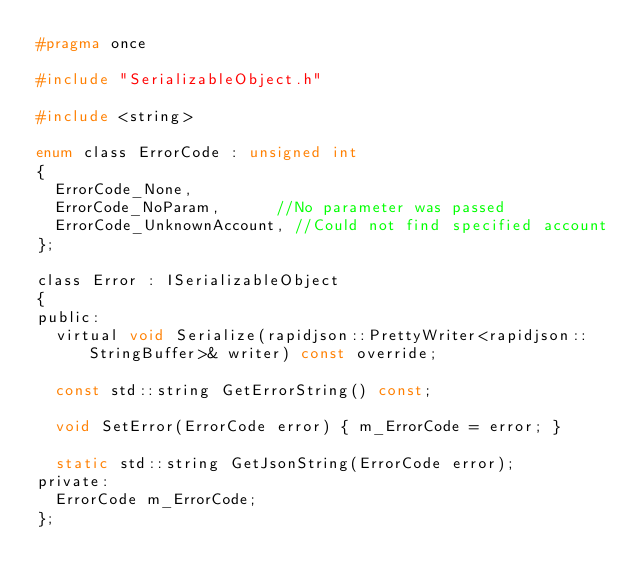<code> <loc_0><loc_0><loc_500><loc_500><_C_>#pragma once

#include "SerializableObject.h"

#include <string>

enum class ErrorCode : unsigned int
{
	ErrorCode_None,
	ErrorCode_NoParam,			//No parameter was passed
	ErrorCode_UnknownAccount,	//Could not find specified account
};

class Error : ISerializableObject
{
public:
	virtual void Serialize(rapidjson::PrettyWriter<rapidjson::StringBuffer>& writer) const override;

	const std::string GetErrorString() const;

	void SetError(ErrorCode error) { m_ErrorCode = error; }

	static std::string GetJsonString(ErrorCode error);
private:
	ErrorCode m_ErrorCode;
};
</code> 